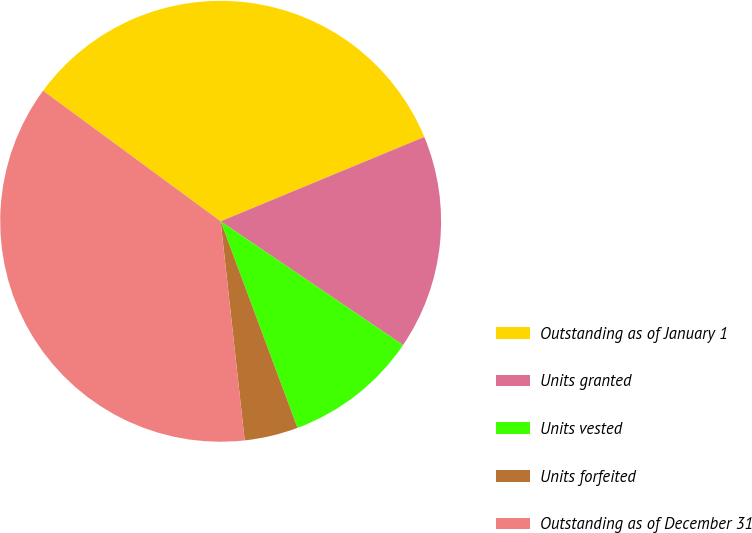<chart> <loc_0><loc_0><loc_500><loc_500><pie_chart><fcel>Outstanding as of January 1<fcel>Units granted<fcel>Units vested<fcel>Units forfeited<fcel>Outstanding as of December 31<nl><fcel>33.66%<fcel>15.74%<fcel>9.84%<fcel>3.93%<fcel>36.83%<nl></chart> 